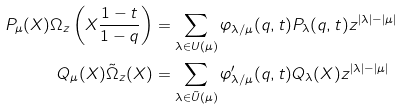Convert formula to latex. <formula><loc_0><loc_0><loc_500><loc_500>P _ { \mu } ( X ) \Omega _ { z } \left ( X \frac { 1 - t } { 1 - q } \right ) & = \sum _ { \lambda \in U ( \mu ) } \varphi _ { \lambda / \mu } ( q , t ) P _ { \lambda } ( q , t ) z ^ { | \lambda | - | \mu | } \\ Q _ { \mu } ( X ) \tilde { \Omega } _ { z } ( X ) & = \sum _ { \lambda \in \tilde { U } ( \mu ) } \varphi ^ { \prime } _ { \lambda / \mu } ( q , t ) Q _ { \lambda } ( X ) z ^ { | \lambda | - | \mu | } \\</formula> 